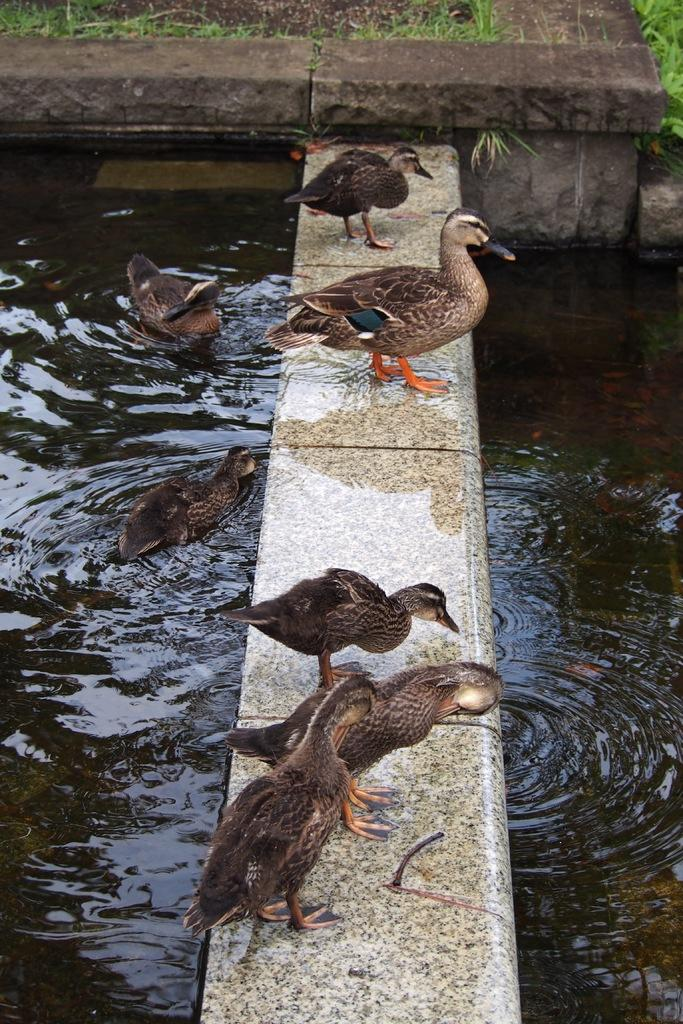What type of animals can be seen in the image? There is a group of birds in the image. Where are the birds located? The birds are on a surface in the image. What can be seen in the background of the image? There is water, grass, and a wall visible in the background of the image. What unit of measurement is being used to determine the distance between the birds' hands? There are no hands visible in the image, as it features a group of birds on a surface. 